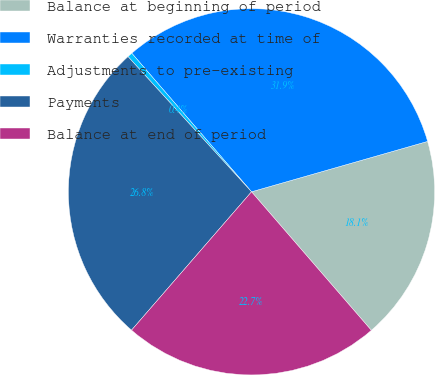<chart> <loc_0><loc_0><loc_500><loc_500><pie_chart><fcel>Balance at beginning of period<fcel>Warranties recorded at time of<fcel>Adjustments to pre-existing<fcel>Payments<fcel>Balance at end of period<nl><fcel>18.09%<fcel>31.91%<fcel>0.44%<fcel>26.85%<fcel>22.72%<nl></chart> 